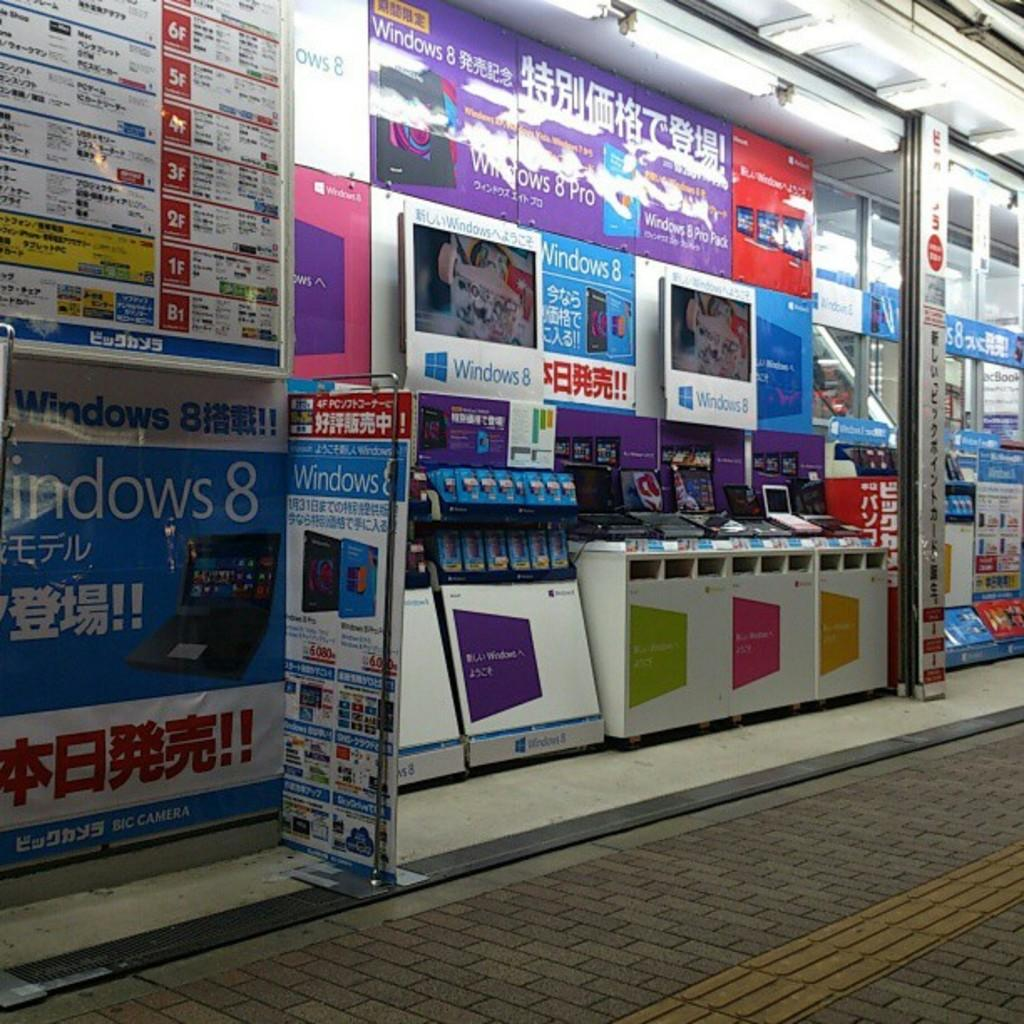<image>
Relay a brief, clear account of the picture shown. Several banners in a store advertise Windows 8. 